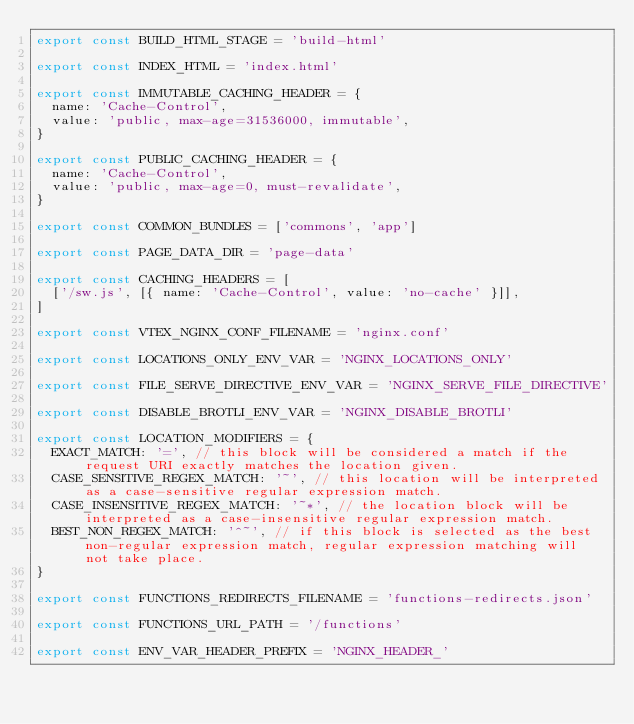Convert code to text. <code><loc_0><loc_0><loc_500><loc_500><_TypeScript_>export const BUILD_HTML_STAGE = 'build-html'

export const INDEX_HTML = 'index.html'

export const IMMUTABLE_CACHING_HEADER = {
  name: 'Cache-Control',
  value: 'public, max-age=31536000, immutable',
}

export const PUBLIC_CACHING_HEADER = {
  name: 'Cache-Control',
  value: 'public, max-age=0, must-revalidate',
}

export const COMMON_BUNDLES = ['commons', 'app']

export const PAGE_DATA_DIR = 'page-data'

export const CACHING_HEADERS = [
  ['/sw.js', [{ name: 'Cache-Control', value: 'no-cache' }]],
]

export const VTEX_NGINX_CONF_FILENAME = 'nginx.conf'

export const LOCATIONS_ONLY_ENV_VAR = 'NGINX_LOCATIONS_ONLY'

export const FILE_SERVE_DIRECTIVE_ENV_VAR = 'NGINX_SERVE_FILE_DIRECTIVE'

export const DISABLE_BROTLI_ENV_VAR = 'NGINX_DISABLE_BROTLI'

export const LOCATION_MODIFIERS = {
  EXACT_MATCH: '=', // this block will be considered a match if the request URI exactly matches the location given.
  CASE_SENSITIVE_REGEX_MATCH: '~', // this location will be interpreted as a case-sensitive regular expression match.
  CASE_INSENSITIVE_REGEX_MATCH: '~*', // the location block will be interpreted as a case-insensitive regular expression match.
  BEST_NON_REGEX_MATCH: '^~', // if this block is selected as the best non-regular expression match, regular expression matching will not take place.
}

export const FUNCTIONS_REDIRECTS_FILENAME = 'functions-redirects.json'

export const FUNCTIONS_URL_PATH = '/functions'

export const ENV_VAR_HEADER_PREFIX = 'NGINX_HEADER_'
</code> 